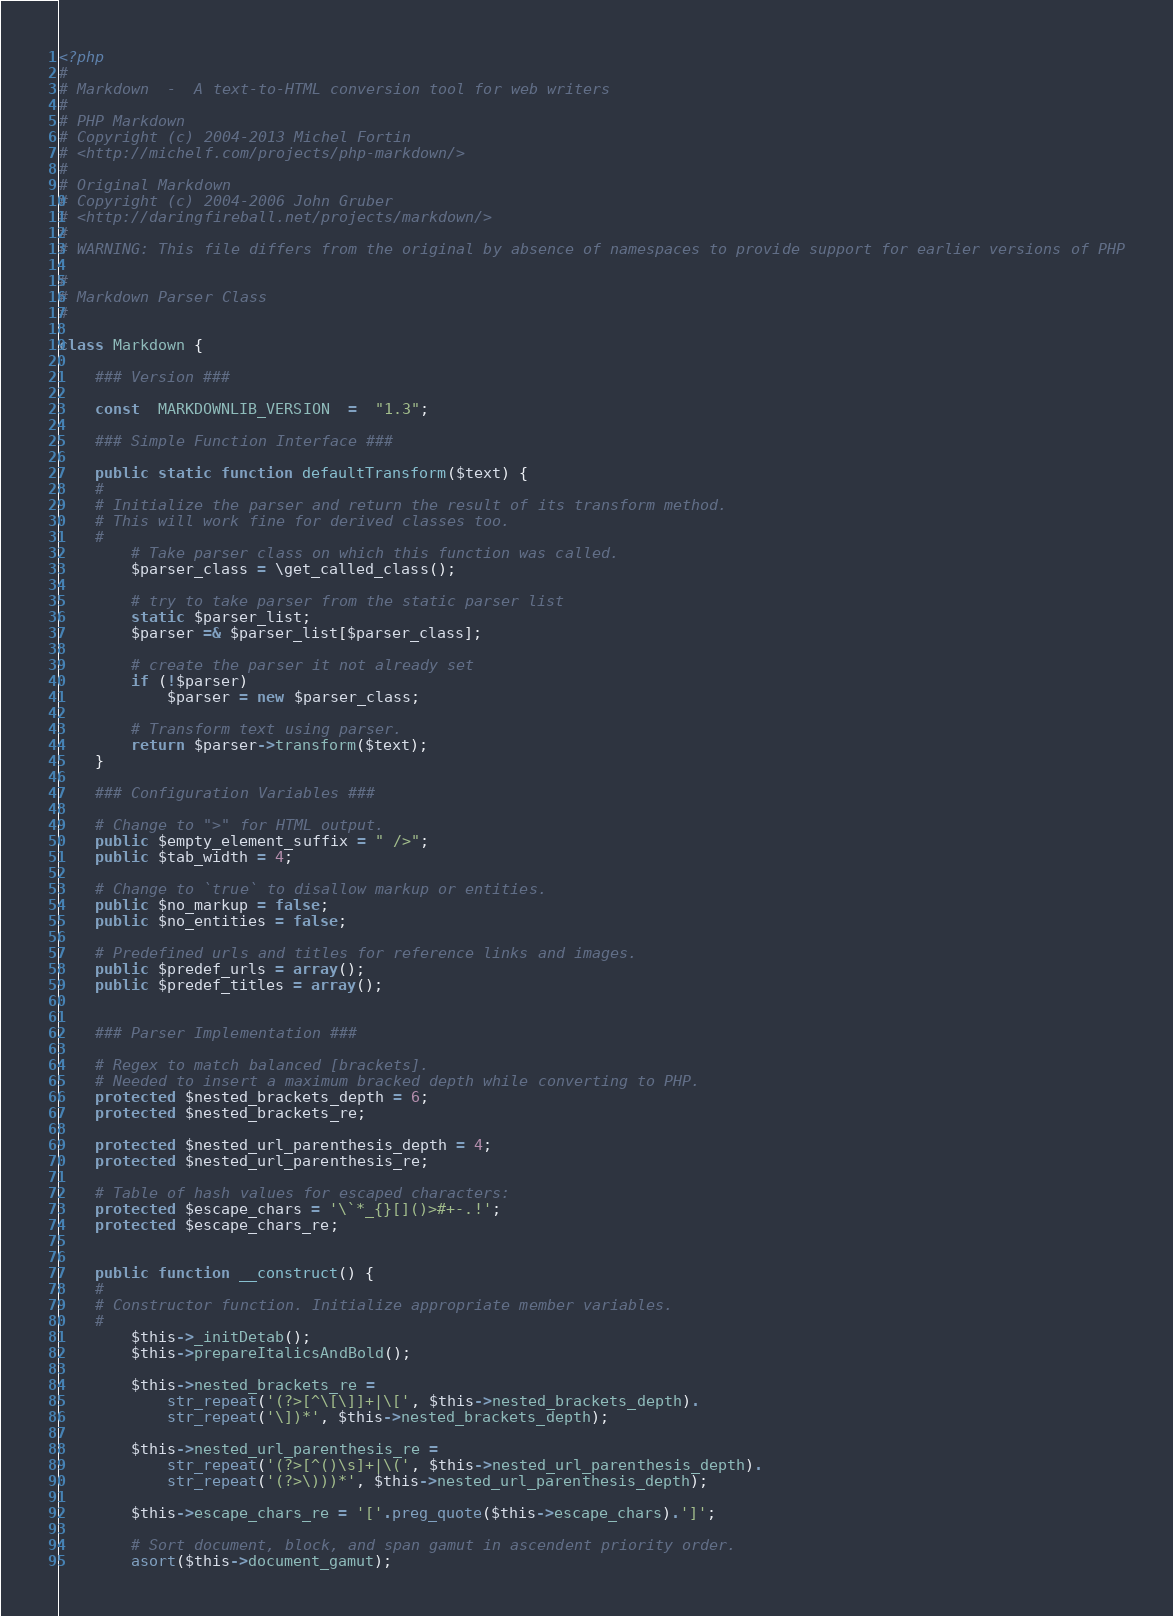<code> <loc_0><loc_0><loc_500><loc_500><_PHP_><?php
#
# Markdown  -  A text-to-HTML conversion tool for web writers
#
# PHP Markdown  
# Copyright (c) 2004-2013 Michel Fortin  
# <http://michelf.com/projects/php-markdown/>
#
# Original Markdown  
# Copyright (c) 2004-2006 John Gruber  
# <http://daringfireball.net/projects/markdown/>
#
# WARNING: This file differs from the original by absence of namespaces to provide support for earlier versions of PHP

#
# Markdown Parser Class
#

class Markdown {

	### Version ###

	const  MARKDOWNLIB_VERSION  =  "1.3";

	### Simple Function Interface ###

	public static function defaultTransform($text) {
	#
	# Initialize the parser and return the result of its transform method.
	# This will work fine for derived classes too.
	#
		# Take parser class on which this function was called.
		$parser_class = \get_called_class();

		# try to take parser from the static parser list
		static $parser_list;
		$parser =& $parser_list[$parser_class];

		# create the parser it not already set
		if (!$parser)
			$parser = new $parser_class;

		# Transform text using parser.
		return $parser->transform($text);
	}

	### Configuration Variables ###

	# Change to ">" for HTML output.
	public $empty_element_suffix = " />";
	public $tab_width = 4;
	
	# Change to `true` to disallow markup or entities.
	public $no_markup = false;
	public $no_entities = false;
	
	# Predefined urls and titles for reference links and images.
	public $predef_urls = array();
	public $predef_titles = array();


	### Parser Implementation ###

	# Regex to match balanced [brackets].
	# Needed to insert a maximum bracked depth while converting to PHP.
	protected $nested_brackets_depth = 6;
	protected $nested_brackets_re;
	
	protected $nested_url_parenthesis_depth = 4;
	protected $nested_url_parenthesis_re;

	# Table of hash values for escaped characters:
	protected $escape_chars = '\`*_{}[]()>#+-.!';
	protected $escape_chars_re;


	public function __construct() {
	#
	# Constructor function. Initialize appropriate member variables.
	#
		$this->_initDetab();
		$this->prepareItalicsAndBold();
	
		$this->nested_brackets_re = 
			str_repeat('(?>[^\[\]]+|\[', $this->nested_brackets_depth).
			str_repeat('\])*', $this->nested_brackets_depth);
	
		$this->nested_url_parenthesis_re = 
			str_repeat('(?>[^()\s]+|\(', $this->nested_url_parenthesis_depth).
			str_repeat('(?>\)))*', $this->nested_url_parenthesis_depth);
		
		$this->escape_chars_re = '['.preg_quote($this->escape_chars).']';
		
		# Sort document, block, and span gamut in ascendent priority order.
		asort($this->document_gamut);</code> 